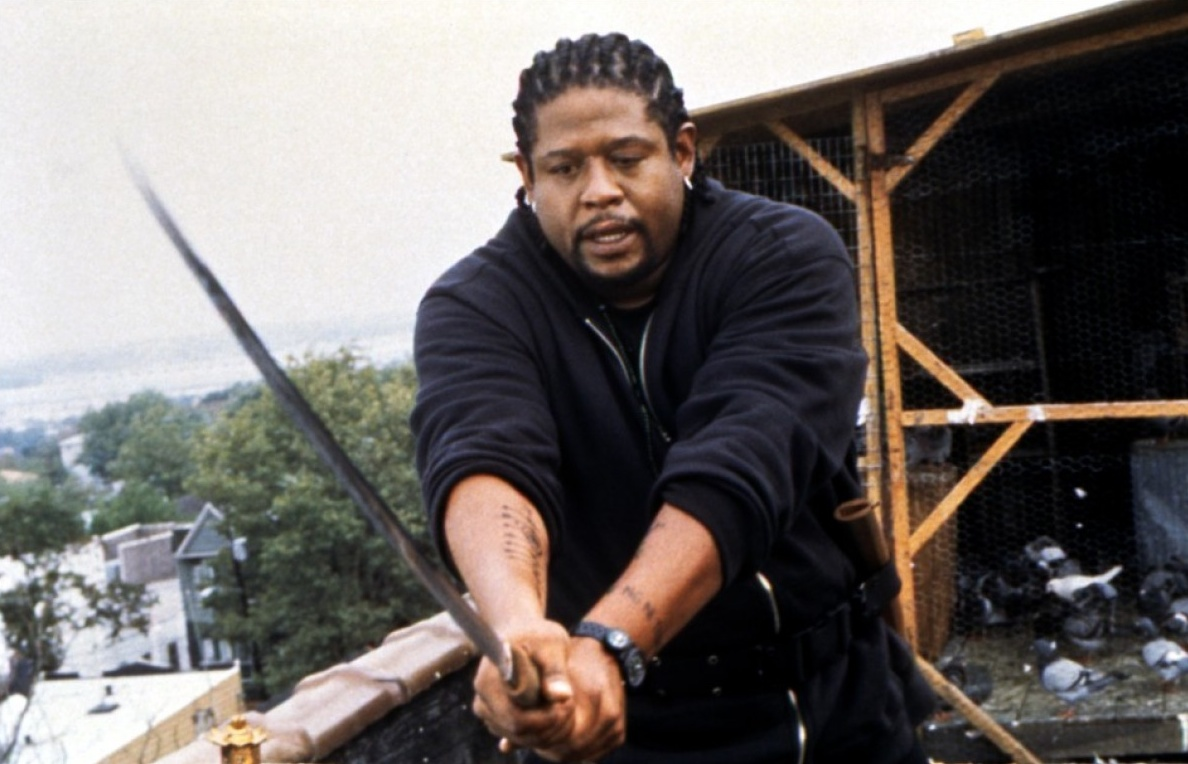What do you think is happening in this scene? This scene appears to be an intense moment, potentially from an action sequence in a film or television series. The individual holding the sword is visibly prepared for combat, with a determined expression and a firm grip on the weapon. The setting, a rooftop with urban surroundings, suggests an element of surprise or ambush. The presence of the pigeons might indicate this is a planned exchange or meeting point. Overall, it seems there is a significant confrontation about to unfold, with high stakes for the character involved. 